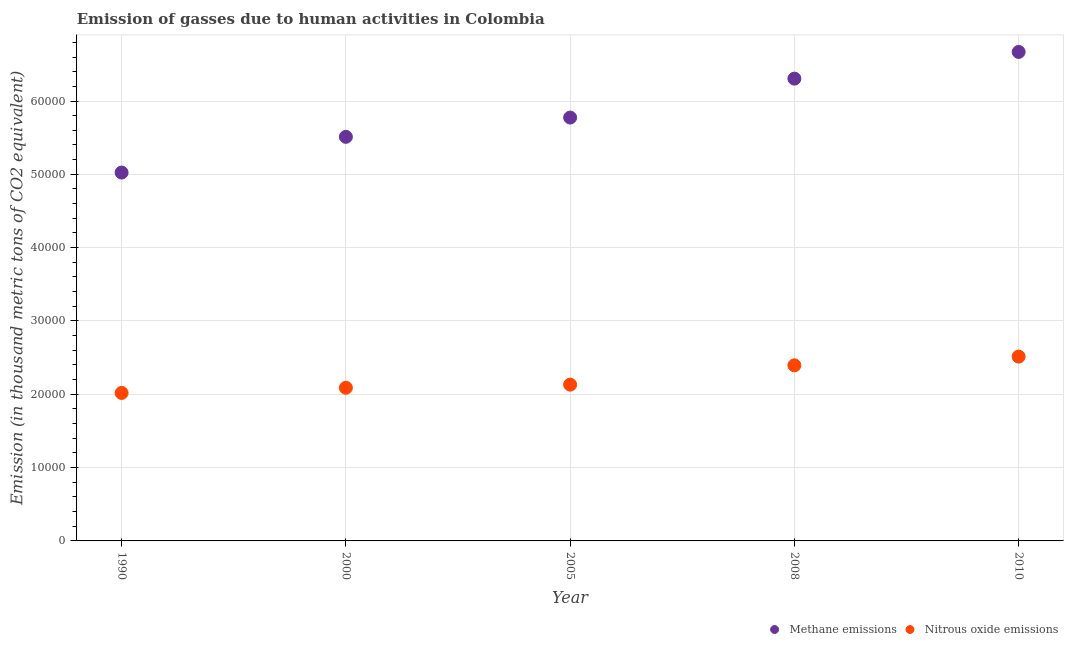What is the amount of methane emissions in 2008?
Keep it short and to the point. 6.31e+04. Across all years, what is the maximum amount of methane emissions?
Offer a terse response. 6.67e+04. Across all years, what is the minimum amount of nitrous oxide emissions?
Give a very brief answer. 2.02e+04. In which year was the amount of nitrous oxide emissions maximum?
Ensure brevity in your answer.  2010. In which year was the amount of nitrous oxide emissions minimum?
Ensure brevity in your answer.  1990. What is the total amount of methane emissions in the graph?
Ensure brevity in your answer.  2.93e+05. What is the difference between the amount of methane emissions in 2000 and that in 2008?
Ensure brevity in your answer.  -7940.3. What is the difference between the amount of nitrous oxide emissions in 1990 and the amount of methane emissions in 2005?
Your answer should be compact. -3.76e+04. What is the average amount of nitrous oxide emissions per year?
Provide a short and direct response. 2.23e+04. In the year 2005, what is the difference between the amount of nitrous oxide emissions and amount of methane emissions?
Your response must be concise. -3.64e+04. In how many years, is the amount of nitrous oxide emissions greater than 4000 thousand metric tons?
Provide a succinct answer. 5. What is the ratio of the amount of nitrous oxide emissions in 2000 to that in 2008?
Keep it short and to the point. 0.87. Is the difference between the amount of nitrous oxide emissions in 2000 and 2008 greater than the difference between the amount of methane emissions in 2000 and 2008?
Keep it short and to the point. Yes. What is the difference between the highest and the second highest amount of methane emissions?
Your answer should be very brief. 3641. What is the difference between the highest and the lowest amount of methane emissions?
Offer a very short reply. 1.65e+04. Is the sum of the amount of methane emissions in 2000 and 2008 greater than the maximum amount of nitrous oxide emissions across all years?
Provide a short and direct response. Yes. How many dotlines are there?
Provide a short and direct response. 2. How many years are there in the graph?
Make the answer very short. 5. Where does the legend appear in the graph?
Make the answer very short. Bottom right. How many legend labels are there?
Offer a very short reply. 2. What is the title of the graph?
Your answer should be very brief. Emission of gasses due to human activities in Colombia. What is the label or title of the X-axis?
Provide a succinct answer. Year. What is the label or title of the Y-axis?
Give a very brief answer. Emission (in thousand metric tons of CO2 equivalent). What is the Emission (in thousand metric tons of CO2 equivalent) in Methane emissions in 1990?
Provide a short and direct response. 5.02e+04. What is the Emission (in thousand metric tons of CO2 equivalent) in Nitrous oxide emissions in 1990?
Provide a short and direct response. 2.02e+04. What is the Emission (in thousand metric tons of CO2 equivalent) of Methane emissions in 2000?
Your answer should be compact. 5.51e+04. What is the Emission (in thousand metric tons of CO2 equivalent) in Nitrous oxide emissions in 2000?
Offer a very short reply. 2.09e+04. What is the Emission (in thousand metric tons of CO2 equivalent) of Methane emissions in 2005?
Your answer should be compact. 5.77e+04. What is the Emission (in thousand metric tons of CO2 equivalent) of Nitrous oxide emissions in 2005?
Your response must be concise. 2.13e+04. What is the Emission (in thousand metric tons of CO2 equivalent) in Methane emissions in 2008?
Ensure brevity in your answer.  6.31e+04. What is the Emission (in thousand metric tons of CO2 equivalent) in Nitrous oxide emissions in 2008?
Make the answer very short. 2.39e+04. What is the Emission (in thousand metric tons of CO2 equivalent) in Methane emissions in 2010?
Provide a succinct answer. 6.67e+04. What is the Emission (in thousand metric tons of CO2 equivalent) of Nitrous oxide emissions in 2010?
Keep it short and to the point. 2.51e+04. Across all years, what is the maximum Emission (in thousand metric tons of CO2 equivalent) in Methane emissions?
Provide a succinct answer. 6.67e+04. Across all years, what is the maximum Emission (in thousand metric tons of CO2 equivalent) in Nitrous oxide emissions?
Make the answer very short. 2.51e+04. Across all years, what is the minimum Emission (in thousand metric tons of CO2 equivalent) of Methane emissions?
Your answer should be very brief. 5.02e+04. Across all years, what is the minimum Emission (in thousand metric tons of CO2 equivalent) in Nitrous oxide emissions?
Your response must be concise. 2.02e+04. What is the total Emission (in thousand metric tons of CO2 equivalent) of Methane emissions in the graph?
Your response must be concise. 2.93e+05. What is the total Emission (in thousand metric tons of CO2 equivalent) of Nitrous oxide emissions in the graph?
Provide a short and direct response. 1.11e+05. What is the difference between the Emission (in thousand metric tons of CO2 equivalent) in Methane emissions in 1990 and that in 2000?
Give a very brief answer. -4870.6. What is the difference between the Emission (in thousand metric tons of CO2 equivalent) in Nitrous oxide emissions in 1990 and that in 2000?
Your answer should be very brief. -706.7. What is the difference between the Emission (in thousand metric tons of CO2 equivalent) in Methane emissions in 1990 and that in 2005?
Give a very brief answer. -7500.3. What is the difference between the Emission (in thousand metric tons of CO2 equivalent) in Nitrous oxide emissions in 1990 and that in 2005?
Your response must be concise. -1134.8. What is the difference between the Emission (in thousand metric tons of CO2 equivalent) in Methane emissions in 1990 and that in 2008?
Give a very brief answer. -1.28e+04. What is the difference between the Emission (in thousand metric tons of CO2 equivalent) in Nitrous oxide emissions in 1990 and that in 2008?
Your answer should be compact. -3767.8. What is the difference between the Emission (in thousand metric tons of CO2 equivalent) of Methane emissions in 1990 and that in 2010?
Your answer should be very brief. -1.65e+04. What is the difference between the Emission (in thousand metric tons of CO2 equivalent) of Nitrous oxide emissions in 1990 and that in 2010?
Ensure brevity in your answer.  -4960.2. What is the difference between the Emission (in thousand metric tons of CO2 equivalent) in Methane emissions in 2000 and that in 2005?
Keep it short and to the point. -2629.7. What is the difference between the Emission (in thousand metric tons of CO2 equivalent) of Nitrous oxide emissions in 2000 and that in 2005?
Your response must be concise. -428.1. What is the difference between the Emission (in thousand metric tons of CO2 equivalent) in Methane emissions in 2000 and that in 2008?
Offer a very short reply. -7940.3. What is the difference between the Emission (in thousand metric tons of CO2 equivalent) of Nitrous oxide emissions in 2000 and that in 2008?
Your response must be concise. -3061.1. What is the difference between the Emission (in thousand metric tons of CO2 equivalent) of Methane emissions in 2000 and that in 2010?
Offer a very short reply. -1.16e+04. What is the difference between the Emission (in thousand metric tons of CO2 equivalent) in Nitrous oxide emissions in 2000 and that in 2010?
Your answer should be compact. -4253.5. What is the difference between the Emission (in thousand metric tons of CO2 equivalent) in Methane emissions in 2005 and that in 2008?
Your response must be concise. -5310.6. What is the difference between the Emission (in thousand metric tons of CO2 equivalent) in Nitrous oxide emissions in 2005 and that in 2008?
Make the answer very short. -2633. What is the difference between the Emission (in thousand metric tons of CO2 equivalent) in Methane emissions in 2005 and that in 2010?
Keep it short and to the point. -8951.6. What is the difference between the Emission (in thousand metric tons of CO2 equivalent) of Nitrous oxide emissions in 2005 and that in 2010?
Your response must be concise. -3825.4. What is the difference between the Emission (in thousand metric tons of CO2 equivalent) in Methane emissions in 2008 and that in 2010?
Offer a very short reply. -3641. What is the difference between the Emission (in thousand metric tons of CO2 equivalent) in Nitrous oxide emissions in 2008 and that in 2010?
Ensure brevity in your answer.  -1192.4. What is the difference between the Emission (in thousand metric tons of CO2 equivalent) in Methane emissions in 1990 and the Emission (in thousand metric tons of CO2 equivalent) in Nitrous oxide emissions in 2000?
Your answer should be very brief. 2.94e+04. What is the difference between the Emission (in thousand metric tons of CO2 equivalent) of Methane emissions in 1990 and the Emission (in thousand metric tons of CO2 equivalent) of Nitrous oxide emissions in 2005?
Provide a short and direct response. 2.89e+04. What is the difference between the Emission (in thousand metric tons of CO2 equivalent) in Methane emissions in 1990 and the Emission (in thousand metric tons of CO2 equivalent) in Nitrous oxide emissions in 2008?
Your answer should be very brief. 2.63e+04. What is the difference between the Emission (in thousand metric tons of CO2 equivalent) in Methane emissions in 1990 and the Emission (in thousand metric tons of CO2 equivalent) in Nitrous oxide emissions in 2010?
Provide a short and direct response. 2.51e+04. What is the difference between the Emission (in thousand metric tons of CO2 equivalent) in Methane emissions in 2000 and the Emission (in thousand metric tons of CO2 equivalent) in Nitrous oxide emissions in 2005?
Offer a terse response. 3.38e+04. What is the difference between the Emission (in thousand metric tons of CO2 equivalent) of Methane emissions in 2000 and the Emission (in thousand metric tons of CO2 equivalent) of Nitrous oxide emissions in 2008?
Your answer should be compact. 3.12e+04. What is the difference between the Emission (in thousand metric tons of CO2 equivalent) of Methane emissions in 2000 and the Emission (in thousand metric tons of CO2 equivalent) of Nitrous oxide emissions in 2010?
Your answer should be compact. 3.00e+04. What is the difference between the Emission (in thousand metric tons of CO2 equivalent) of Methane emissions in 2005 and the Emission (in thousand metric tons of CO2 equivalent) of Nitrous oxide emissions in 2008?
Your response must be concise. 3.38e+04. What is the difference between the Emission (in thousand metric tons of CO2 equivalent) in Methane emissions in 2005 and the Emission (in thousand metric tons of CO2 equivalent) in Nitrous oxide emissions in 2010?
Offer a very short reply. 3.26e+04. What is the difference between the Emission (in thousand metric tons of CO2 equivalent) of Methane emissions in 2008 and the Emission (in thousand metric tons of CO2 equivalent) of Nitrous oxide emissions in 2010?
Offer a terse response. 3.79e+04. What is the average Emission (in thousand metric tons of CO2 equivalent) of Methane emissions per year?
Offer a terse response. 5.86e+04. What is the average Emission (in thousand metric tons of CO2 equivalent) in Nitrous oxide emissions per year?
Provide a succinct answer. 2.23e+04. In the year 1990, what is the difference between the Emission (in thousand metric tons of CO2 equivalent) of Methane emissions and Emission (in thousand metric tons of CO2 equivalent) of Nitrous oxide emissions?
Give a very brief answer. 3.01e+04. In the year 2000, what is the difference between the Emission (in thousand metric tons of CO2 equivalent) in Methane emissions and Emission (in thousand metric tons of CO2 equivalent) in Nitrous oxide emissions?
Offer a terse response. 3.42e+04. In the year 2005, what is the difference between the Emission (in thousand metric tons of CO2 equivalent) of Methane emissions and Emission (in thousand metric tons of CO2 equivalent) of Nitrous oxide emissions?
Provide a succinct answer. 3.64e+04. In the year 2008, what is the difference between the Emission (in thousand metric tons of CO2 equivalent) in Methane emissions and Emission (in thousand metric tons of CO2 equivalent) in Nitrous oxide emissions?
Offer a terse response. 3.91e+04. In the year 2010, what is the difference between the Emission (in thousand metric tons of CO2 equivalent) of Methane emissions and Emission (in thousand metric tons of CO2 equivalent) of Nitrous oxide emissions?
Offer a very short reply. 4.16e+04. What is the ratio of the Emission (in thousand metric tons of CO2 equivalent) of Methane emissions in 1990 to that in 2000?
Give a very brief answer. 0.91. What is the ratio of the Emission (in thousand metric tons of CO2 equivalent) in Nitrous oxide emissions in 1990 to that in 2000?
Offer a very short reply. 0.97. What is the ratio of the Emission (in thousand metric tons of CO2 equivalent) of Methane emissions in 1990 to that in 2005?
Make the answer very short. 0.87. What is the ratio of the Emission (in thousand metric tons of CO2 equivalent) in Nitrous oxide emissions in 1990 to that in 2005?
Your response must be concise. 0.95. What is the ratio of the Emission (in thousand metric tons of CO2 equivalent) in Methane emissions in 1990 to that in 2008?
Your answer should be very brief. 0.8. What is the ratio of the Emission (in thousand metric tons of CO2 equivalent) in Nitrous oxide emissions in 1990 to that in 2008?
Offer a very short reply. 0.84. What is the ratio of the Emission (in thousand metric tons of CO2 equivalent) in Methane emissions in 1990 to that in 2010?
Offer a very short reply. 0.75. What is the ratio of the Emission (in thousand metric tons of CO2 equivalent) of Nitrous oxide emissions in 1990 to that in 2010?
Your response must be concise. 0.8. What is the ratio of the Emission (in thousand metric tons of CO2 equivalent) of Methane emissions in 2000 to that in 2005?
Your answer should be compact. 0.95. What is the ratio of the Emission (in thousand metric tons of CO2 equivalent) in Nitrous oxide emissions in 2000 to that in 2005?
Give a very brief answer. 0.98. What is the ratio of the Emission (in thousand metric tons of CO2 equivalent) in Methane emissions in 2000 to that in 2008?
Keep it short and to the point. 0.87. What is the ratio of the Emission (in thousand metric tons of CO2 equivalent) in Nitrous oxide emissions in 2000 to that in 2008?
Your answer should be very brief. 0.87. What is the ratio of the Emission (in thousand metric tons of CO2 equivalent) in Methane emissions in 2000 to that in 2010?
Provide a short and direct response. 0.83. What is the ratio of the Emission (in thousand metric tons of CO2 equivalent) of Nitrous oxide emissions in 2000 to that in 2010?
Make the answer very short. 0.83. What is the ratio of the Emission (in thousand metric tons of CO2 equivalent) of Methane emissions in 2005 to that in 2008?
Offer a very short reply. 0.92. What is the ratio of the Emission (in thousand metric tons of CO2 equivalent) of Nitrous oxide emissions in 2005 to that in 2008?
Offer a very short reply. 0.89. What is the ratio of the Emission (in thousand metric tons of CO2 equivalent) in Methane emissions in 2005 to that in 2010?
Give a very brief answer. 0.87. What is the ratio of the Emission (in thousand metric tons of CO2 equivalent) in Nitrous oxide emissions in 2005 to that in 2010?
Ensure brevity in your answer.  0.85. What is the ratio of the Emission (in thousand metric tons of CO2 equivalent) of Methane emissions in 2008 to that in 2010?
Offer a very short reply. 0.95. What is the ratio of the Emission (in thousand metric tons of CO2 equivalent) of Nitrous oxide emissions in 2008 to that in 2010?
Your answer should be very brief. 0.95. What is the difference between the highest and the second highest Emission (in thousand metric tons of CO2 equivalent) of Methane emissions?
Ensure brevity in your answer.  3641. What is the difference between the highest and the second highest Emission (in thousand metric tons of CO2 equivalent) of Nitrous oxide emissions?
Keep it short and to the point. 1192.4. What is the difference between the highest and the lowest Emission (in thousand metric tons of CO2 equivalent) of Methane emissions?
Provide a short and direct response. 1.65e+04. What is the difference between the highest and the lowest Emission (in thousand metric tons of CO2 equivalent) in Nitrous oxide emissions?
Offer a terse response. 4960.2. 